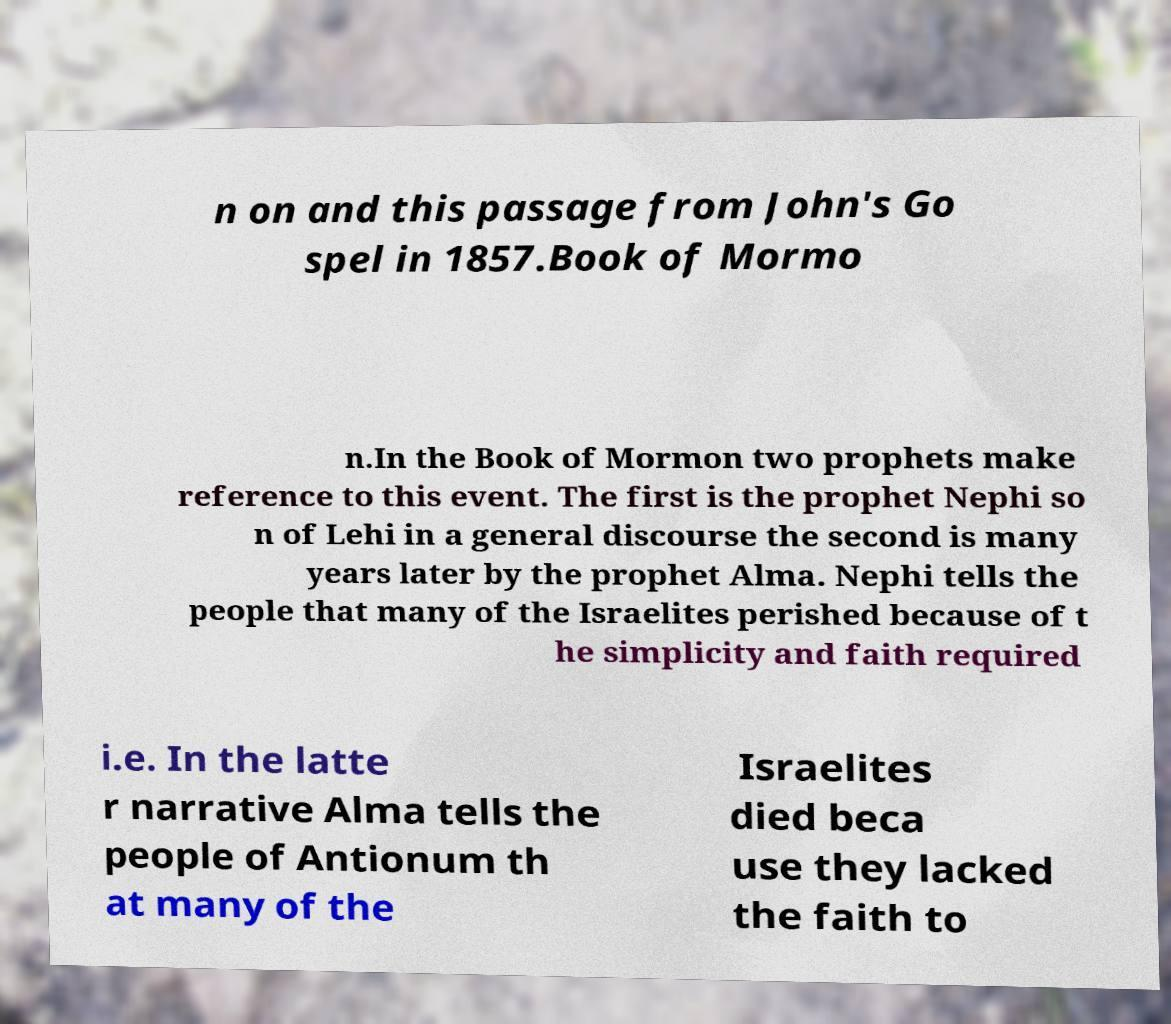For documentation purposes, I need the text within this image transcribed. Could you provide that? n on and this passage from John's Go spel in 1857.Book of Mormo n.In the Book of Mormon two prophets make reference to this event. The first is the prophet Nephi so n of Lehi in a general discourse the second is many years later by the prophet Alma. Nephi tells the people that many of the Israelites perished because of t he simplicity and faith required i.e. In the latte r narrative Alma tells the people of Antionum th at many of the Israelites died beca use they lacked the faith to 